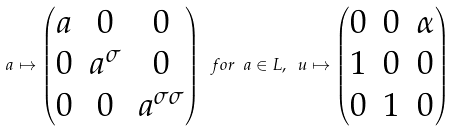<formula> <loc_0><loc_0><loc_500><loc_500>a \mapsto \begin{pmatrix} a & 0 & 0 \\ 0 & a ^ { \sigma } & 0 \\ 0 & 0 & a ^ { \sigma \sigma } \end{pmatrix} \ f o r \ a \in L , \ u \mapsto \begin{pmatrix} 0 & 0 & \alpha \\ 1 & 0 & 0 \\ 0 & 1 & 0 \end{pmatrix}</formula> 